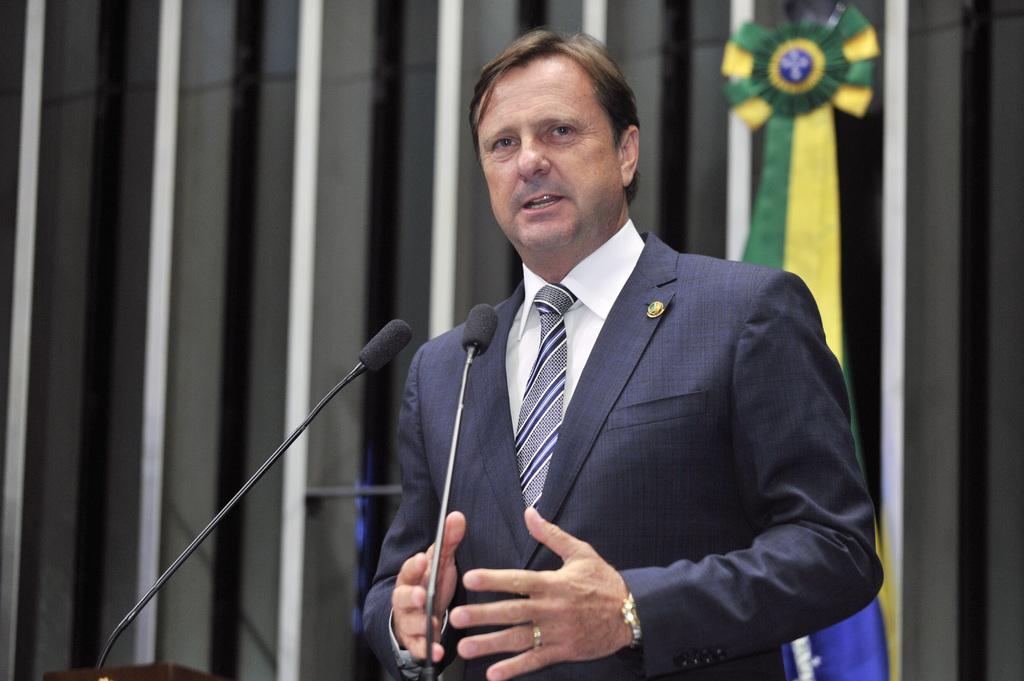What is the main subject of the image? There is a person standing in the center of the image. What objects are in front of the person? There are two microphones in front of the person. What can be seen in the background of the image? There is a wall in the background of the image, and there is a green and yellow color object. How many pars are flying over the person's head in the image? There are no pars present in the image. 